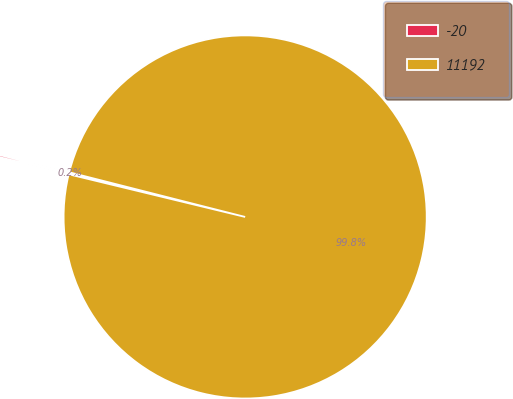<chart> <loc_0><loc_0><loc_500><loc_500><pie_chart><fcel>-20<fcel>11192<nl><fcel>0.18%<fcel>99.82%<nl></chart> 